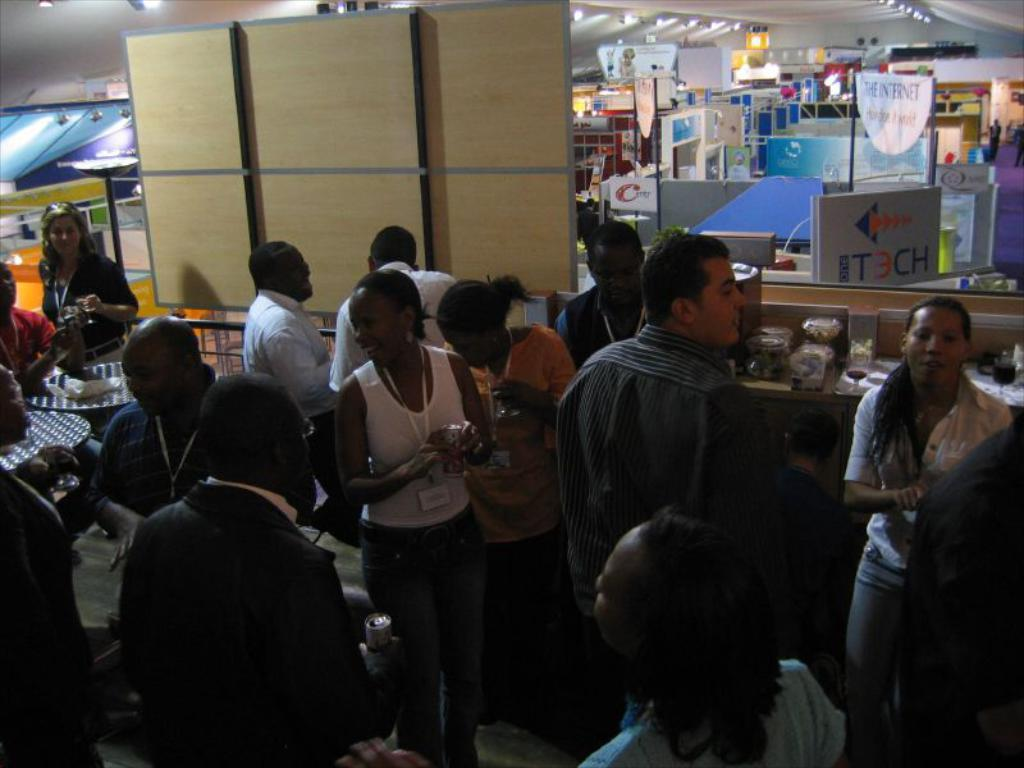What can be seen in the foreground of the image? There are persons standing in the foreground of the image. What is the cardboard used for in the image? The cardboard is used to hold objects in the image. Can you describe the objects on the cardboard? Unfortunately, the facts provided do not give any details about the objects on the cardboard. What type of rabbit is hopping around the cardboard in the image? There is no rabbit present in the image. What idea does the cardboard represent in the image? The facts provided do not mention any ideas associated with the cardboard. 